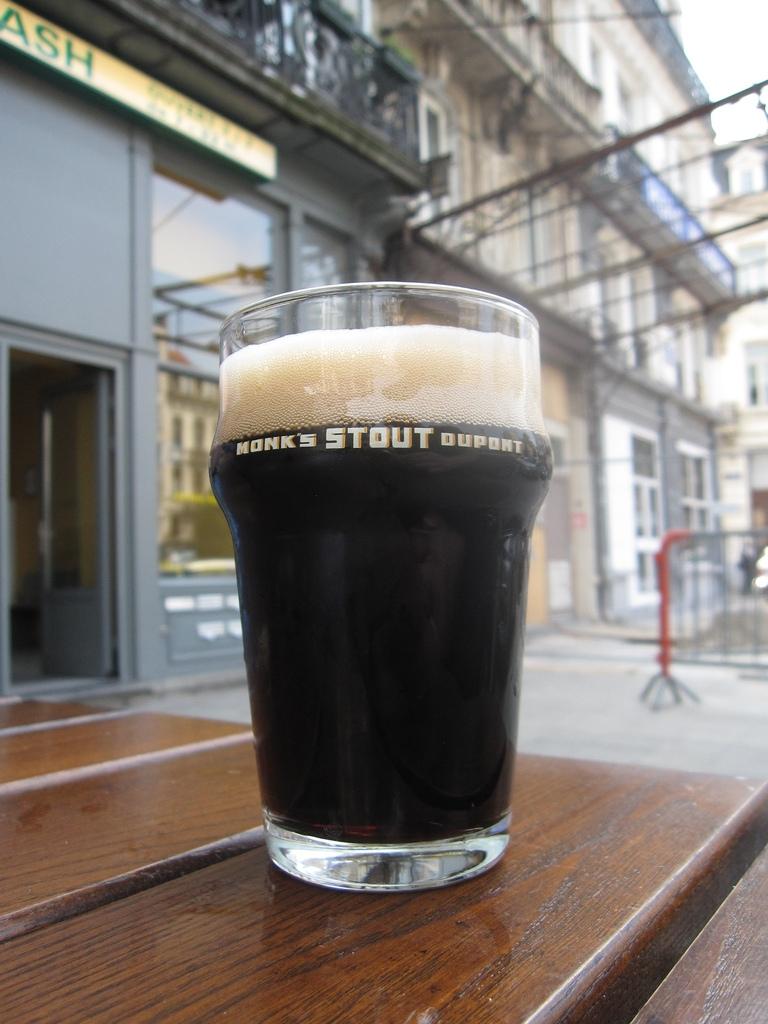What kind of drink is this?
Give a very brief answer. Stout. 